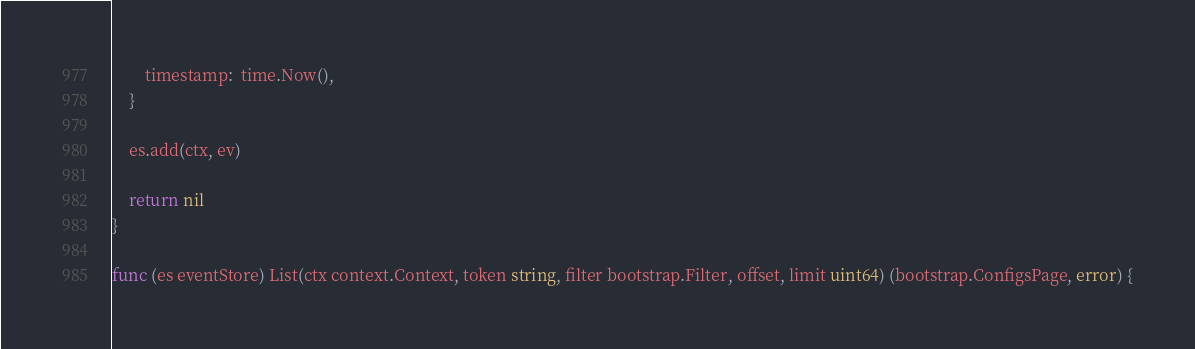<code> <loc_0><loc_0><loc_500><loc_500><_Go_>		timestamp:  time.Now(),
	}

	es.add(ctx, ev)

	return nil
}

func (es eventStore) List(ctx context.Context, token string, filter bootstrap.Filter, offset, limit uint64) (bootstrap.ConfigsPage, error) {</code> 